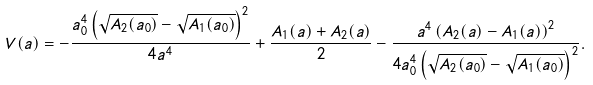Convert formula to latex. <formula><loc_0><loc_0><loc_500><loc_500>V ( a ) = - \frac { a _ { 0 } ^ { 4 } \left ( \sqrt { A _ { 2 } ( a _ { 0 } ) } - \sqrt { A _ { 1 } ( a _ { 0 } ) } \right ) ^ { 2 } } { 4 a ^ { 4 } } + \frac { A _ { 1 } ( a ) + A _ { 2 } ( a ) } { 2 } - \frac { a ^ { 4 } \left ( A _ { 2 } ( a ) - A _ { 1 } ( a ) \right ) ^ { 2 } } { 4 a _ { 0 } ^ { 4 } \left ( \sqrt { A _ { 2 } ( a _ { 0 } ) } - \sqrt { A _ { 1 } ( a _ { 0 } ) } \right ) ^ { 2 } } .</formula> 